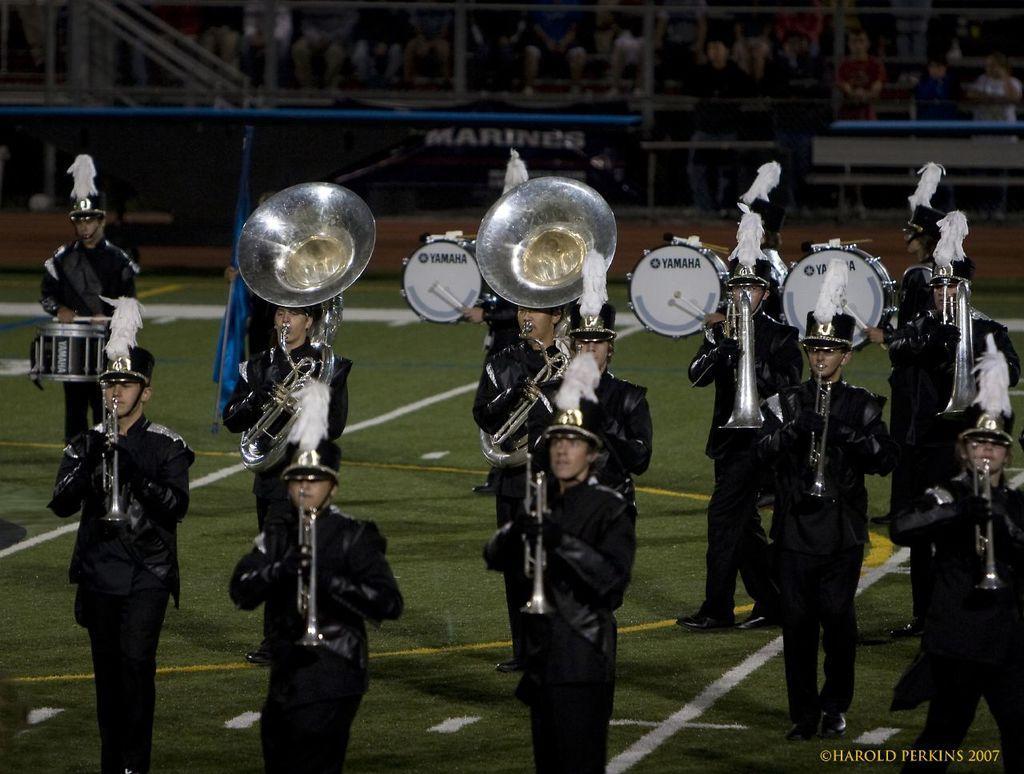Can you describe this image briefly? In this image, there are persons in uniform, playing musical instruments on the ground, on which there are yellow and white color lines and there is grass. On the bottom right, there is a watermark. In the background, there is a fence, there are persons and other objects. 